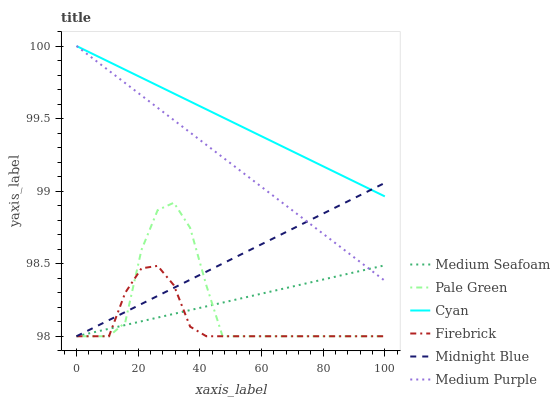Does Firebrick have the minimum area under the curve?
Answer yes or no. Yes. Does Cyan have the maximum area under the curve?
Answer yes or no. Yes. Does Medium Purple have the minimum area under the curve?
Answer yes or no. No. Does Medium Purple have the maximum area under the curve?
Answer yes or no. No. Is Medium Purple the smoothest?
Answer yes or no. Yes. Is Pale Green the roughest?
Answer yes or no. Yes. Is Firebrick the smoothest?
Answer yes or no. No. Is Firebrick the roughest?
Answer yes or no. No. Does Midnight Blue have the lowest value?
Answer yes or no. Yes. Does Medium Purple have the lowest value?
Answer yes or no. No. Does Cyan have the highest value?
Answer yes or no. Yes. Does Firebrick have the highest value?
Answer yes or no. No. Is Firebrick less than Medium Purple?
Answer yes or no. Yes. Is Medium Purple greater than Pale Green?
Answer yes or no. Yes. Does Midnight Blue intersect Medium Seafoam?
Answer yes or no. Yes. Is Midnight Blue less than Medium Seafoam?
Answer yes or no. No. Is Midnight Blue greater than Medium Seafoam?
Answer yes or no. No. Does Firebrick intersect Medium Purple?
Answer yes or no. No. 